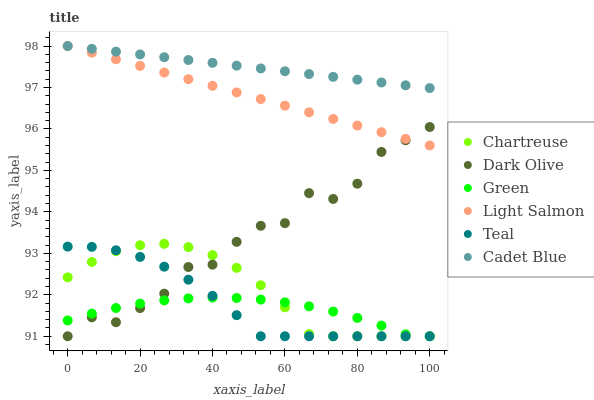Does Green have the minimum area under the curve?
Answer yes or no. Yes. Does Cadet Blue have the maximum area under the curve?
Answer yes or no. Yes. Does Dark Olive have the minimum area under the curve?
Answer yes or no. No. Does Dark Olive have the maximum area under the curve?
Answer yes or no. No. Is Cadet Blue the smoothest?
Answer yes or no. Yes. Is Dark Olive the roughest?
Answer yes or no. Yes. Is Dark Olive the smoothest?
Answer yes or no. No. Is Cadet Blue the roughest?
Answer yes or no. No. Does Dark Olive have the lowest value?
Answer yes or no. Yes. Does Cadet Blue have the lowest value?
Answer yes or no. No. Does Cadet Blue have the highest value?
Answer yes or no. Yes. Does Dark Olive have the highest value?
Answer yes or no. No. Is Dark Olive less than Cadet Blue?
Answer yes or no. Yes. Is Cadet Blue greater than Chartreuse?
Answer yes or no. Yes. Does Teal intersect Green?
Answer yes or no. Yes. Is Teal less than Green?
Answer yes or no. No. Is Teal greater than Green?
Answer yes or no. No. Does Dark Olive intersect Cadet Blue?
Answer yes or no. No. 